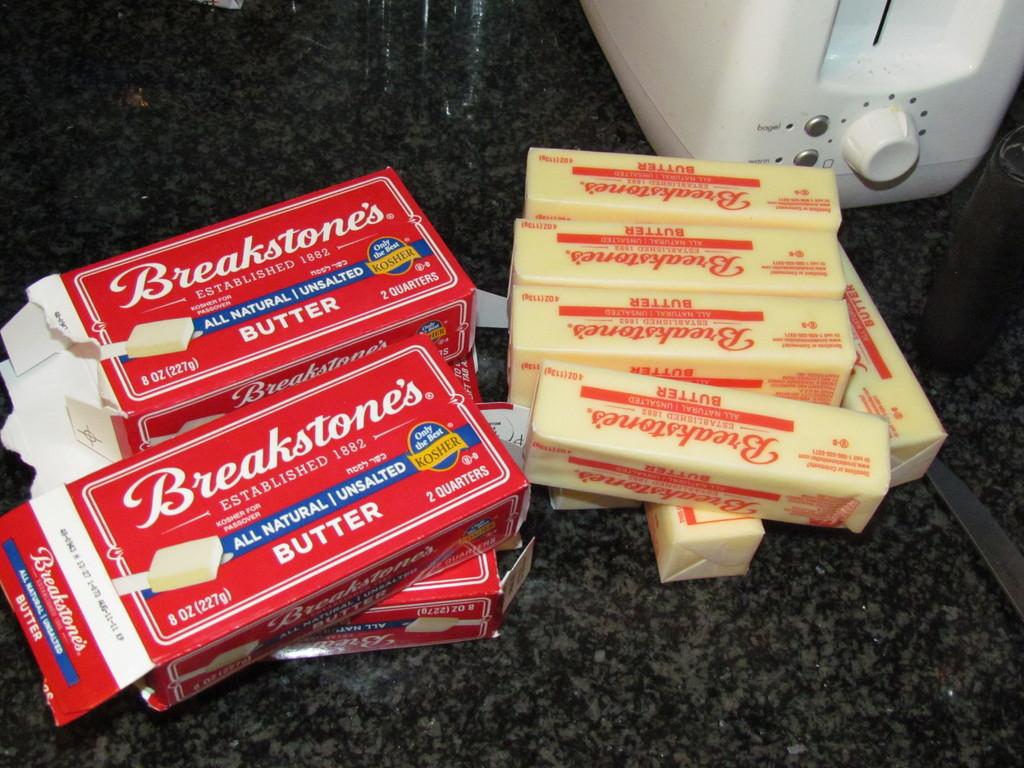What brand is this butter?
Give a very brief answer. Breakstone's. What company logo is printed on the butter container?
Your answer should be compact. Breakstone's. 